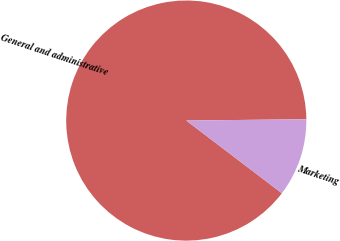<chart> <loc_0><loc_0><loc_500><loc_500><pie_chart><fcel>General and administrative<fcel>Marketing<nl><fcel>89.47%<fcel>10.53%<nl></chart> 